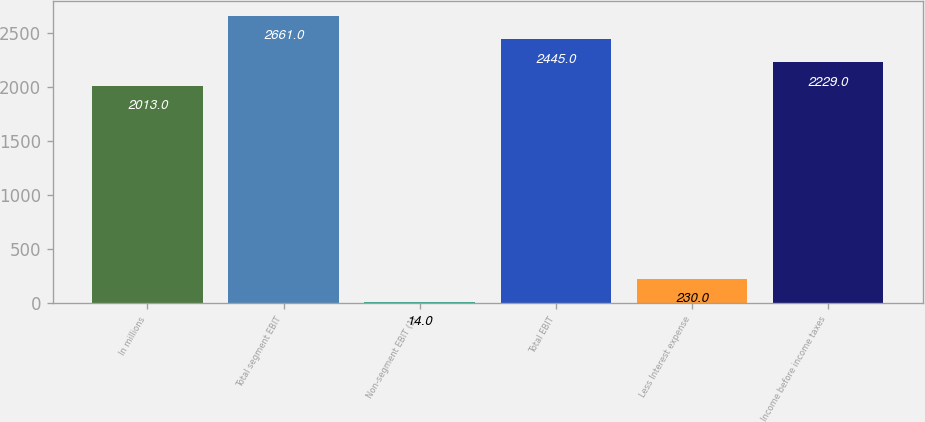<chart> <loc_0><loc_0><loc_500><loc_500><bar_chart><fcel>In millions<fcel>Total segment EBIT<fcel>Non-segment EBIT (1)<fcel>Total EBIT<fcel>Less Interest expense<fcel>Income before income taxes<nl><fcel>2013<fcel>2661<fcel>14<fcel>2445<fcel>230<fcel>2229<nl></chart> 